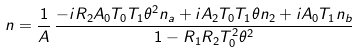Convert formula to latex. <formula><loc_0><loc_0><loc_500><loc_500>n = \frac { 1 } { A } \, \frac { - i R _ { 2 } A _ { 0 } T _ { 0 } T _ { 1 } \theta ^ { 2 } n _ { a } + i A _ { 2 } T _ { 0 } T _ { 1 } \theta n _ { 2 } + i A _ { 0 } T _ { 1 } n _ { b } } { 1 - R _ { 1 } R _ { 2 } T _ { 0 } ^ { 2 } \theta ^ { 2 } }</formula> 